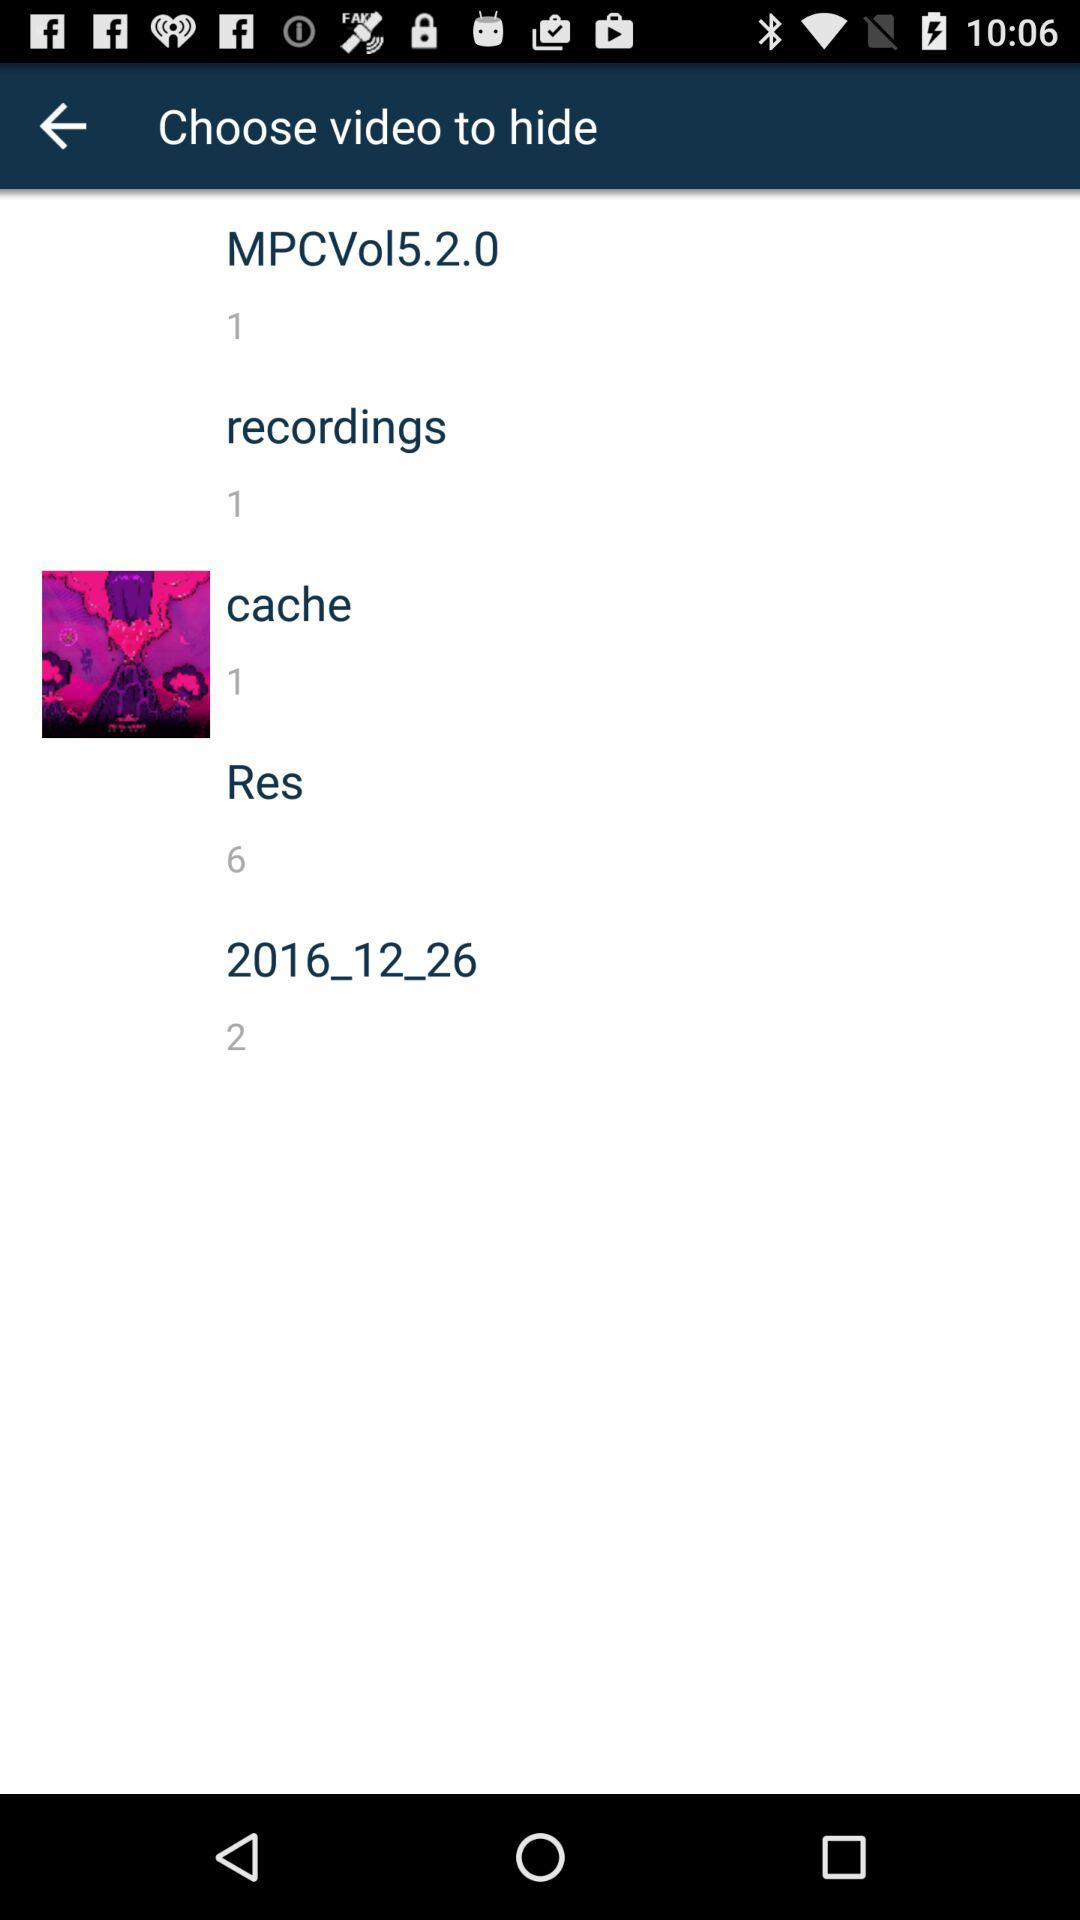How long are the recordings?
When the provided information is insufficient, respond with <no answer>. <no answer> 